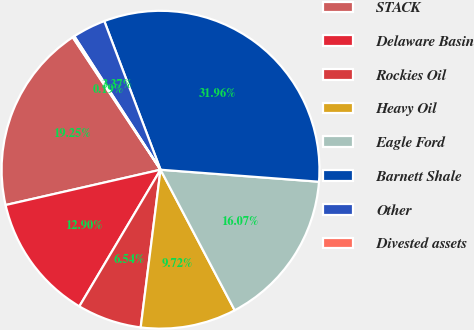<chart> <loc_0><loc_0><loc_500><loc_500><pie_chart><fcel>STACK<fcel>Delaware Basin<fcel>Rockies Oil<fcel>Heavy Oil<fcel>Eagle Ford<fcel>Barnett Shale<fcel>Other<fcel>Divested assets<nl><fcel>19.25%<fcel>12.9%<fcel>6.54%<fcel>9.72%<fcel>16.07%<fcel>31.96%<fcel>3.37%<fcel>0.19%<nl></chart> 